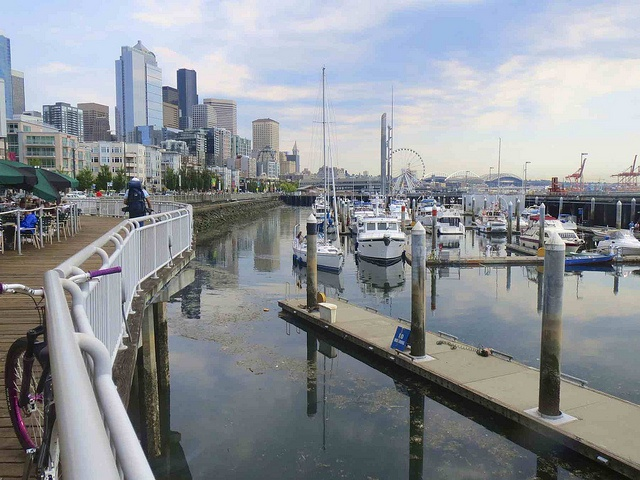Describe the objects in this image and their specific colors. I can see bicycle in lightblue, black, gray, darkgray, and lightgray tones, boat in lightblue, darkgray, lightgray, gray, and black tones, boat in lightblue, darkgray, gray, lightgray, and black tones, boat in lightblue, darkgray, lightgray, and gray tones, and people in lightblue, black, navy, gray, and darkgray tones in this image. 